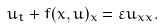Convert formula to latex. <formula><loc_0><loc_0><loc_500><loc_500>u _ { t } + f ( x , u ) _ { x } = \varepsilon u _ { x x } .</formula> 